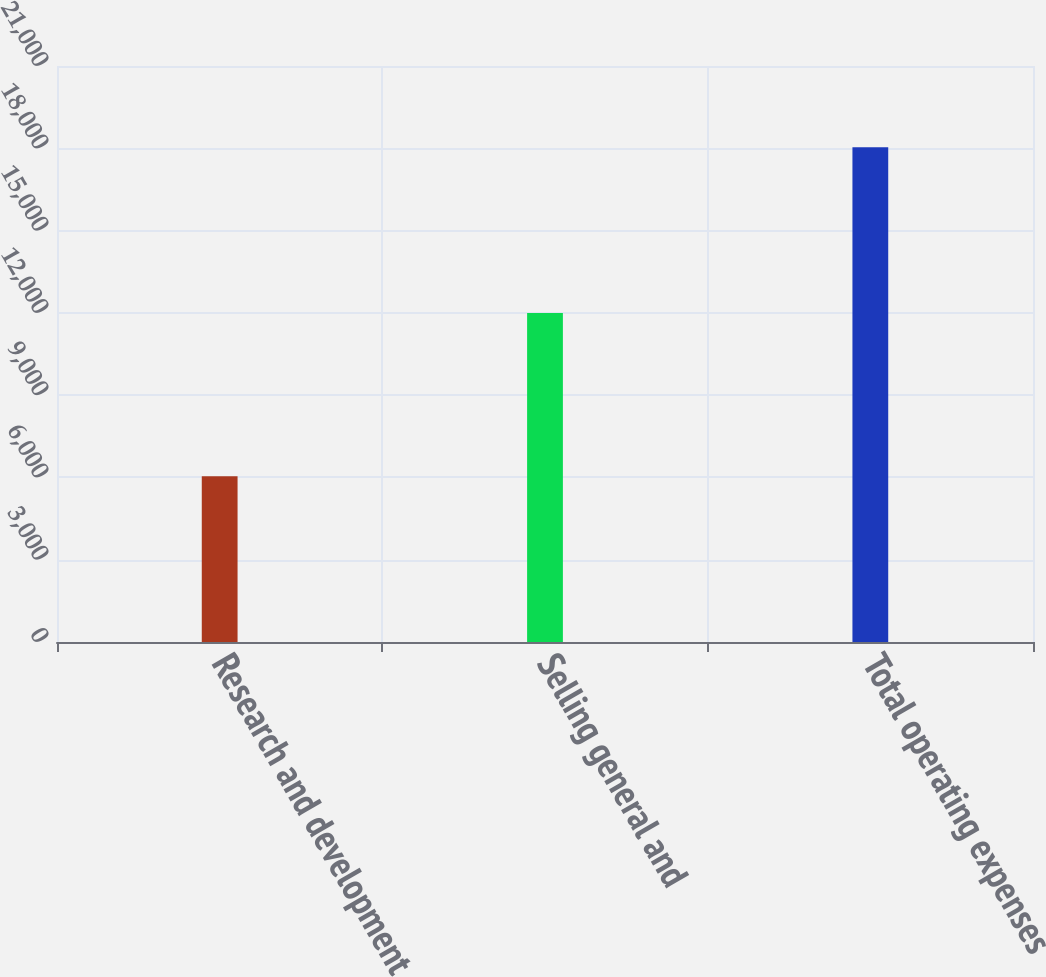Convert chart to OTSL. <chart><loc_0><loc_0><loc_500><loc_500><bar_chart><fcel>Research and development<fcel>Selling general and<fcel>Total operating expenses<nl><fcel>6041<fcel>11993<fcel>18034<nl></chart> 